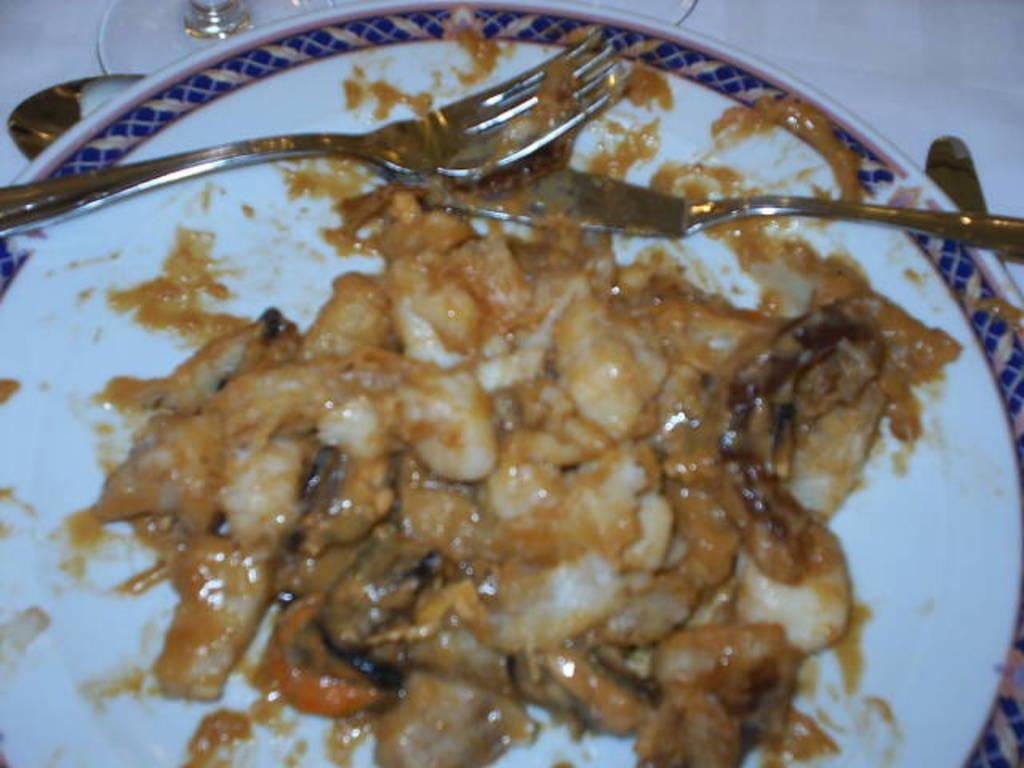What is on the plate in the image? There is a food item on a plate in the image. What utensils are on the plate? There is a fork and a knife on the plate. Where is the spoon located in the image? The spoon is in the image, but not on the plate. What can be seen partially in the image? Part of a glass is visible in the image. What is the color of the background in the image? The background of the image is white. What type of writing can be seen on the food item in the image? There is no writing visible on the food item in the image. What type of string is used to tie the utensils together in the image? There are no strings used to tie the utensils together in the image; they are separate on the plate. 